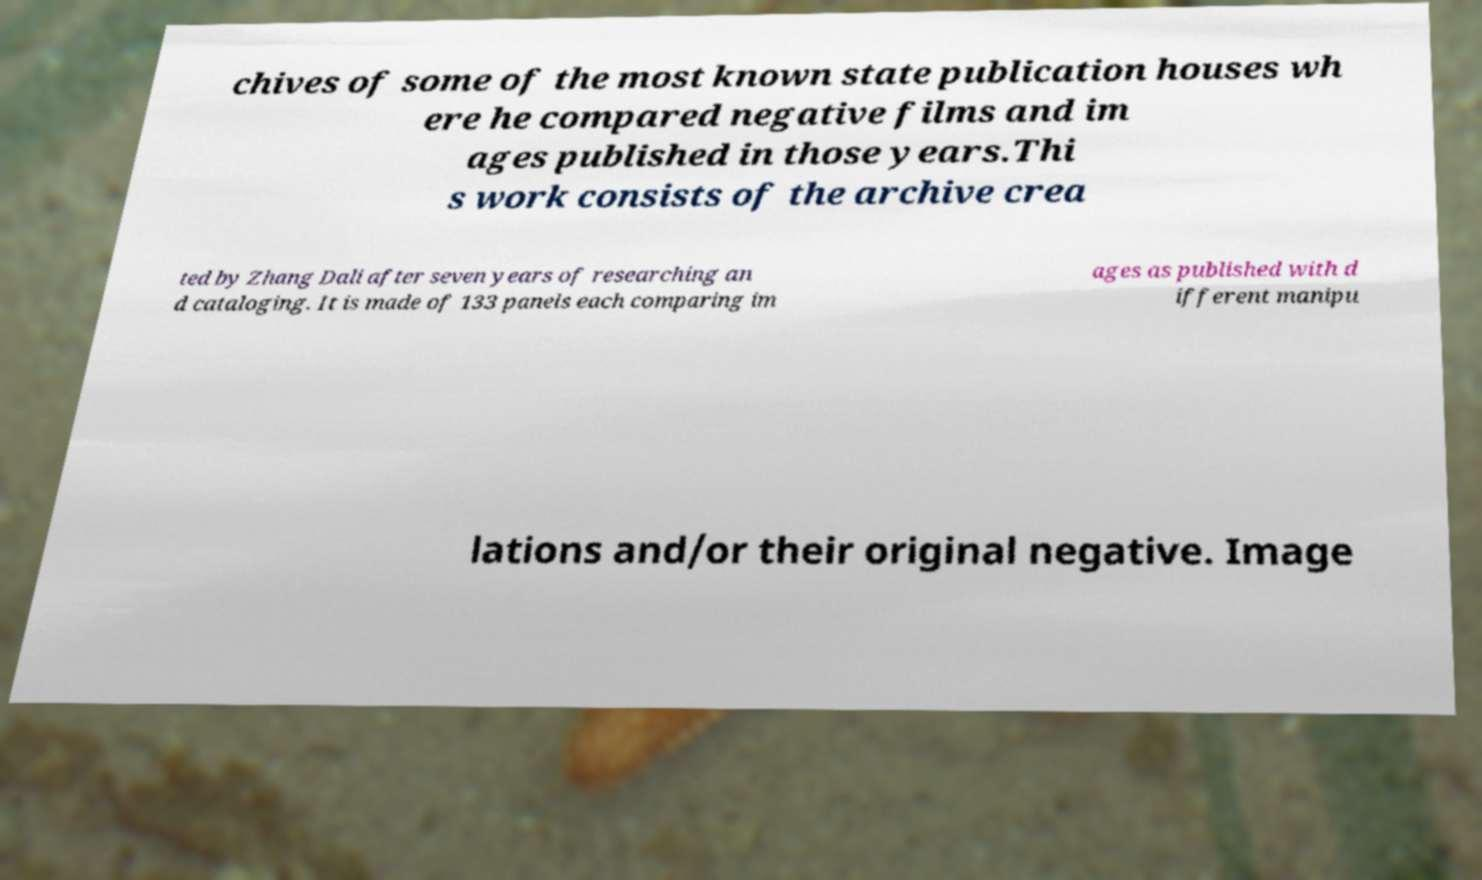Could you extract and type out the text from this image? chives of some of the most known state publication houses wh ere he compared negative films and im ages published in those years.Thi s work consists of the archive crea ted by Zhang Dali after seven years of researching an d cataloging. It is made of 133 panels each comparing im ages as published with d ifferent manipu lations and/or their original negative. Image 